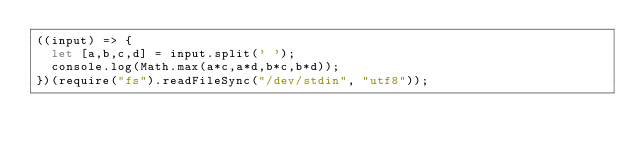<code> <loc_0><loc_0><loc_500><loc_500><_JavaScript_>((input) => {
  let [a,b,c,d] = input.split(' ');
  console.log(Math.max(a*c,a*d,b*c,b*d));
})(require("fs").readFileSync("/dev/stdin", "utf8"));</code> 